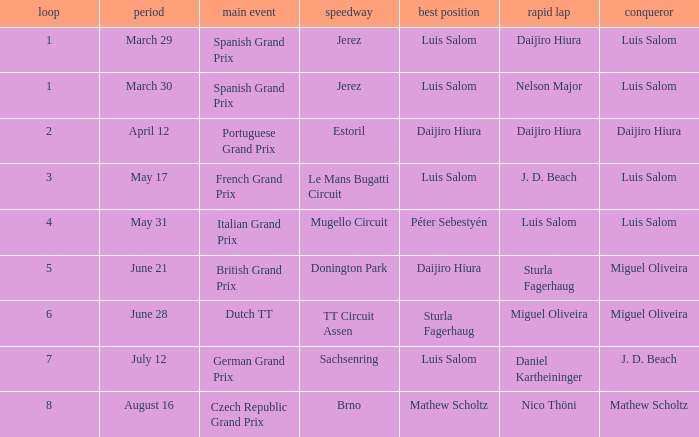Which round 5 Grand Prix had Daijiro Hiura at pole position?  British Grand Prix. 